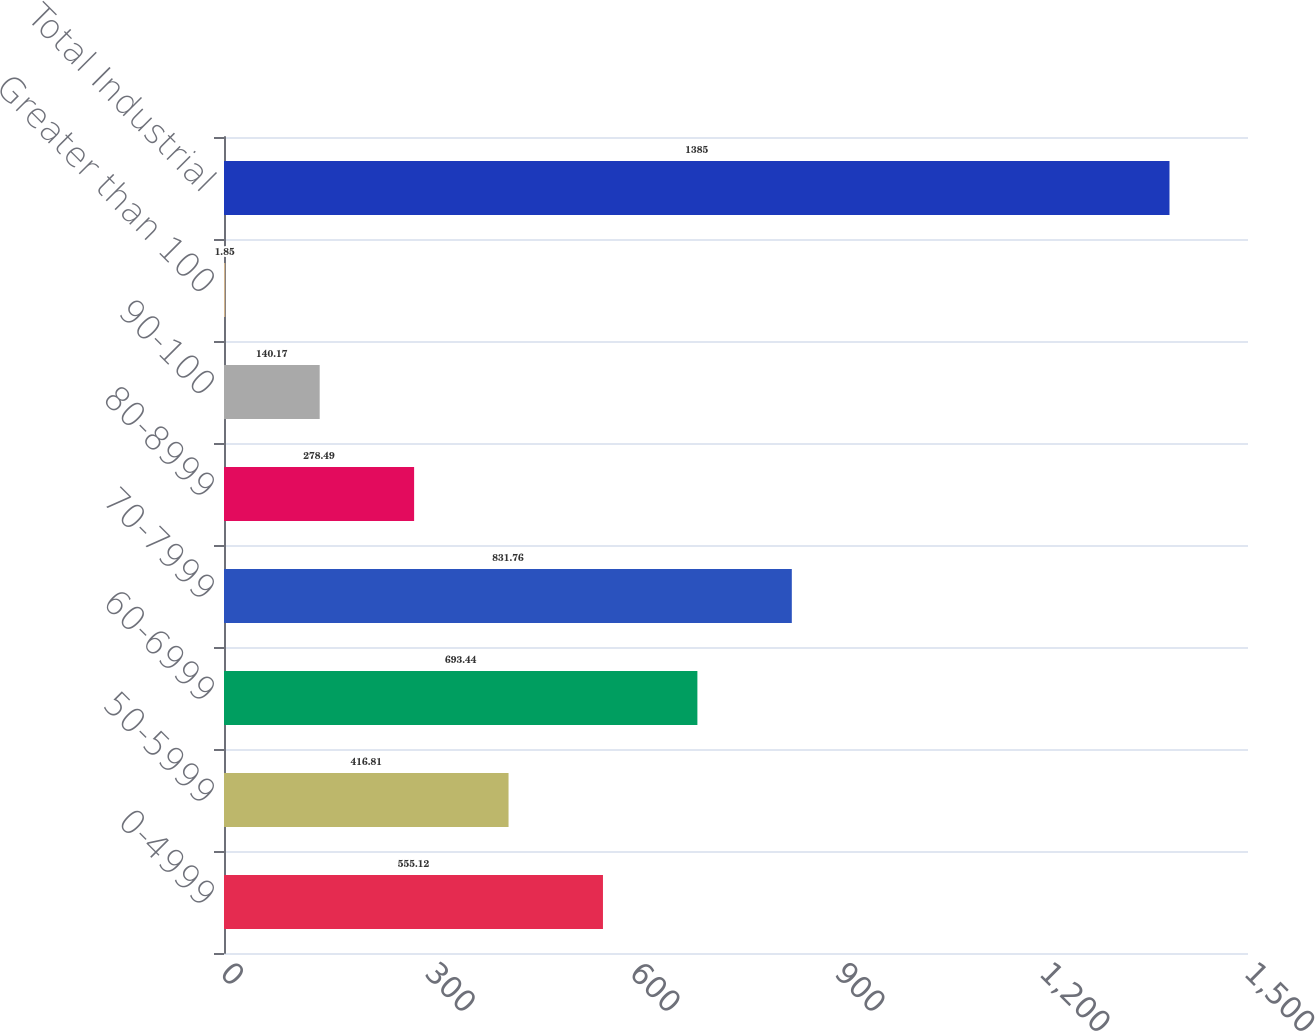Convert chart to OTSL. <chart><loc_0><loc_0><loc_500><loc_500><bar_chart><fcel>0-4999<fcel>50-5999<fcel>60-6999<fcel>70-7999<fcel>80-8999<fcel>90-100<fcel>Greater than 100<fcel>Total Industrial<nl><fcel>555.12<fcel>416.81<fcel>693.44<fcel>831.76<fcel>278.49<fcel>140.17<fcel>1.85<fcel>1385<nl></chart> 